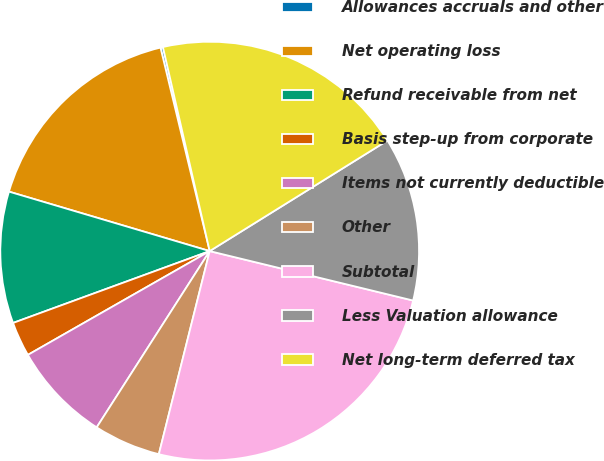<chart> <loc_0><loc_0><loc_500><loc_500><pie_chart><fcel>Allowances accruals and other<fcel>Net operating loss<fcel>Refund receivable from net<fcel>Basis step-up from corporate<fcel>Items not currently deductible<fcel>Other<fcel>Subtotal<fcel>Less Valuation allowance<fcel>Net long-term deferred tax<nl><fcel>0.19%<fcel>16.64%<fcel>10.16%<fcel>2.68%<fcel>7.67%<fcel>5.17%<fcel>25.11%<fcel>12.65%<fcel>19.73%<nl></chart> 